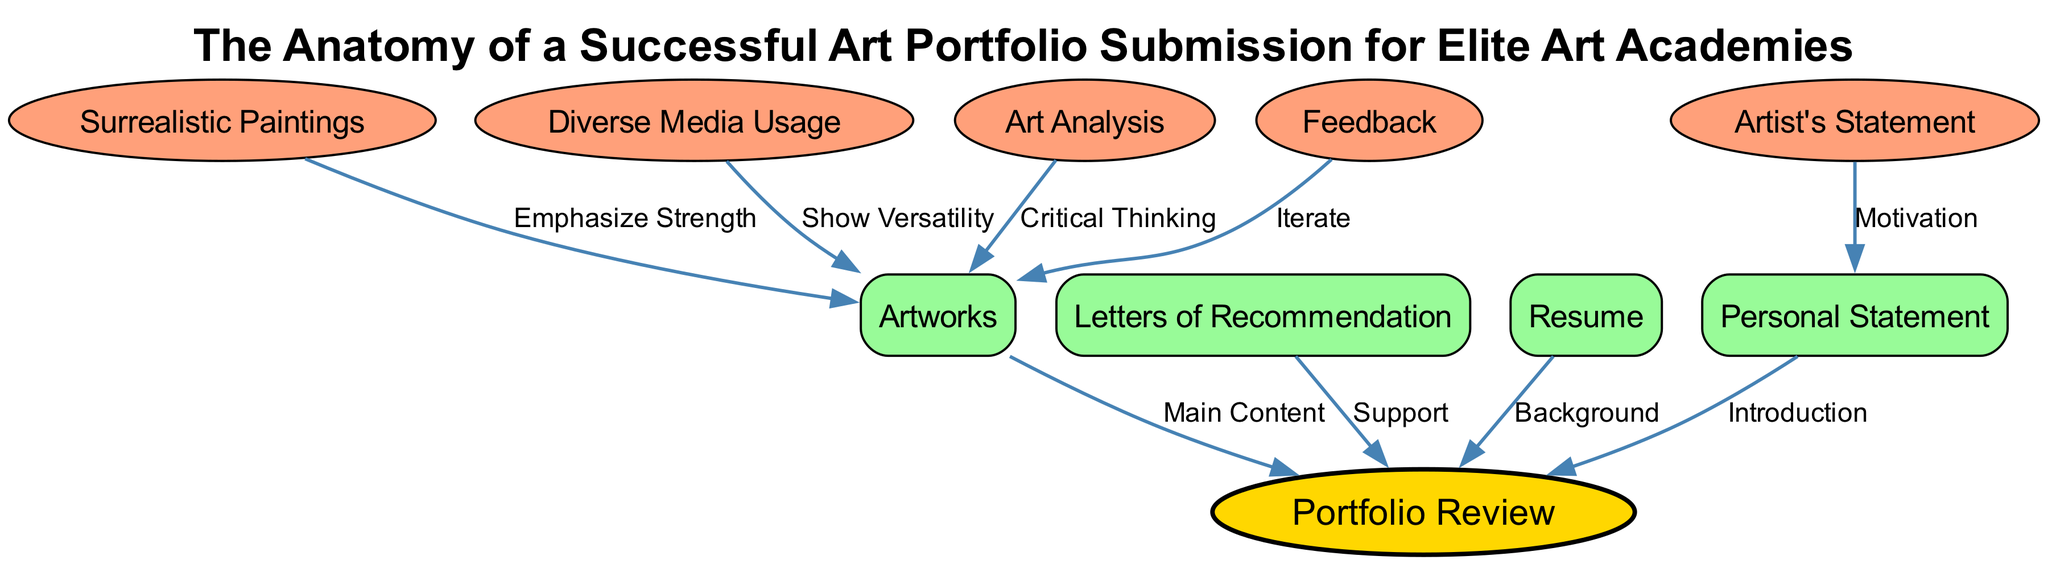What is the title of the diagram? The title of the diagram is presented at the top center of the visual. The text "The Anatomy of a Successful Art Portfolio Submission for Elite Art Academies" is clearly labeled as the title, making it easily identifiable.
Answer: The Anatomy of a Successful Art Portfolio Submission for Elite Art Academies How many nodes are present in the diagram? To find the total number of nodes, count each individual section labeled in the diagram. There are 10 distinct nodes listed, which include components like personal statement, artworks, and others.
Answer: 10 What type of node is "portfolio review"? Examining the style and shape used for the "portfolio review" node specifically, it is depicted as an oval shape, which denotes it as a key feature in the diagram.
Answer: Oval What is the relationship between "personal statement" and "portfolio review"? Following the connection line from "personal statement" to "portfolio review," we can see it is labeled "Introduction," indicating the role of the personal statement in the overall portfolio review process.
Answer: Introduction What does "media diversity" emphasize in relation to "artworks"? The edge connecting "media diversity" and "artworks" is labeled "Show Versatility." This labeling indicates that "media diversity" communicates the importance of showcasing various artistic techniques and materials in the artworks.
Answer: Show Versatility What element supports the "portfolio review"? Looking at the edges going to the "portfolio review" node, one of them is from "recommendations," labeled "Support." This shows that letters of recommendation play a supportive role in the portfolio review process.
Answer: Letters of Recommendation Which node is directly linked to the "art analysis" node? By tracking the edges connected to "art analysis," it leads us to "artworks," indicating that the artwork should demonstrate critical thinking as suggested by the relationship depicted.
Answer: Artworks What does the "feedback" node influence in this diagram? The "feedback" node connects to "artworks" with the label "Iterate." This indicates that feedback allows for iterative improvements to one's artworks, suggesting a process of refinement based on critiques received.
Answer: Artworks What is the purpose of the "artist's statement" in the context of the "personal statement"? The connection from "artist's statement" to "personal statement" is labeled "Motivation," which shows that the artist's statement helps provide motivation behind the personal statement, enhancing the overall narrative.
Answer: Motivation 